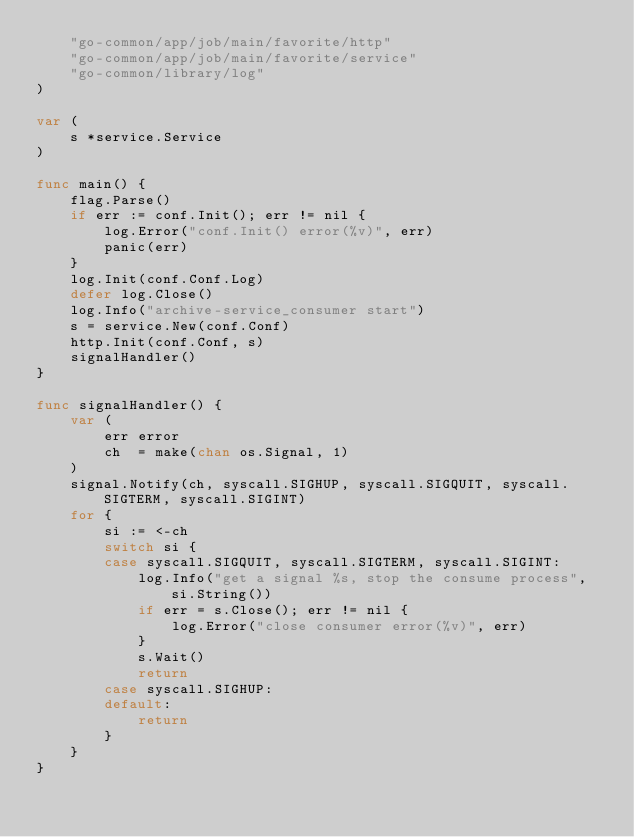<code> <loc_0><loc_0><loc_500><loc_500><_Go_>	"go-common/app/job/main/favorite/http"
	"go-common/app/job/main/favorite/service"
	"go-common/library/log"
)

var (
	s *service.Service
)

func main() {
	flag.Parse()
	if err := conf.Init(); err != nil {
		log.Error("conf.Init() error(%v)", err)
		panic(err)
	}
	log.Init(conf.Conf.Log)
	defer log.Close()
	log.Info("archive-service_consumer start")
	s = service.New(conf.Conf)
	http.Init(conf.Conf, s)
	signalHandler()
}

func signalHandler() {
	var (
		err error
		ch  = make(chan os.Signal, 1)
	)
	signal.Notify(ch, syscall.SIGHUP, syscall.SIGQUIT, syscall.SIGTERM, syscall.SIGINT)
	for {
		si := <-ch
		switch si {
		case syscall.SIGQUIT, syscall.SIGTERM, syscall.SIGINT:
			log.Info("get a signal %s, stop the consume process", si.String())
			if err = s.Close(); err != nil {
				log.Error("close consumer error(%v)", err)
			}
			s.Wait()
			return
		case syscall.SIGHUP:
		default:
			return
		}
	}
}
</code> 